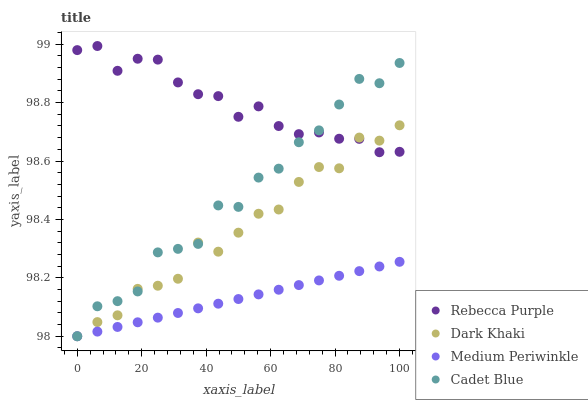Does Medium Periwinkle have the minimum area under the curve?
Answer yes or no. Yes. Does Rebecca Purple have the maximum area under the curve?
Answer yes or no. Yes. Does Cadet Blue have the minimum area under the curve?
Answer yes or no. No. Does Cadet Blue have the maximum area under the curve?
Answer yes or no. No. Is Medium Periwinkle the smoothest?
Answer yes or no. Yes. Is Cadet Blue the roughest?
Answer yes or no. Yes. Is Cadet Blue the smoothest?
Answer yes or no. No. Is Medium Periwinkle the roughest?
Answer yes or no. No. Does Dark Khaki have the lowest value?
Answer yes or no. Yes. Does Rebecca Purple have the lowest value?
Answer yes or no. No. Does Rebecca Purple have the highest value?
Answer yes or no. Yes. Does Cadet Blue have the highest value?
Answer yes or no. No. Is Medium Periwinkle less than Rebecca Purple?
Answer yes or no. Yes. Is Rebecca Purple greater than Medium Periwinkle?
Answer yes or no. Yes. Does Rebecca Purple intersect Dark Khaki?
Answer yes or no. Yes. Is Rebecca Purple less than Dark Khaki?
Answer yes or no. No. Is Rebecca Purple greater than Dark Khaki?
Answer yes or no. No. Does Medium Periwinkle intersect Rebecca Purple?
Answer yes or no. No. 